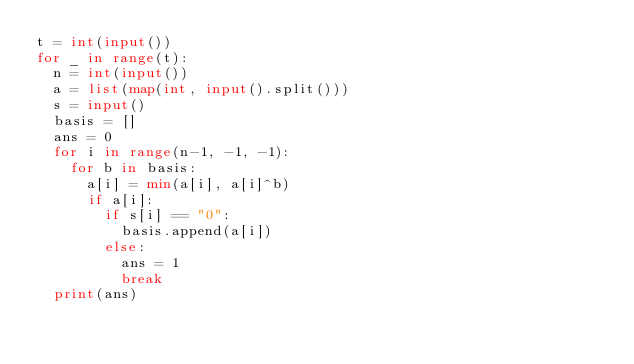Convert code to text. <code><loc_0><loc_0><loc_500><loc_500><_Python_>t = int(input())
for _ in range(t):
	n = int(input())
	a = list(map(int, input().split()))
	s = input()
	basis = []
	ans = 0
	for i in range(n-1, -1, -1):
		for b in basis:
			a[i] = min(a[i], a[i]^b)
			if a[i]:
				if s[i] == "0":
					basis.append(a[i])
				else:
					ans = 1
					break
	print(ans)</code> 